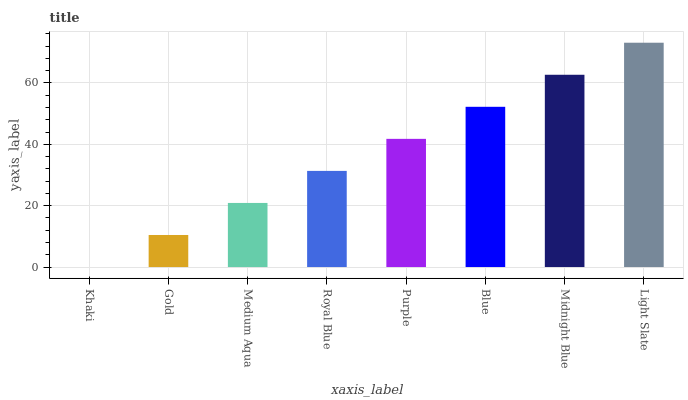Is Khaki the minimum?
Answer yes or no. Yes. Is Light Slate the maximum?
Answer yes or no. Yes. Is Gold the minimum?
Answer yes or no. No. Is Gold the maximum?
Answer yes or no. No. Is Gold greater than Khaki?
Answer yes or no. Yes. Is Khaki less than Gold?
Answer yes or no. Yes. Is Khaki greater than Gold?
Answer yes or no. No. Is Gold less than Khaki?
Answer yes or no. No. Is Purple the high median?
Answer yes or no. Yes. Is Royal Blue the low median?
Answer yes or no. Yes. Is Midnight Blue the high median?
Answer yes or no. No. Is Gold the low median?
Answer yes or no. No. 